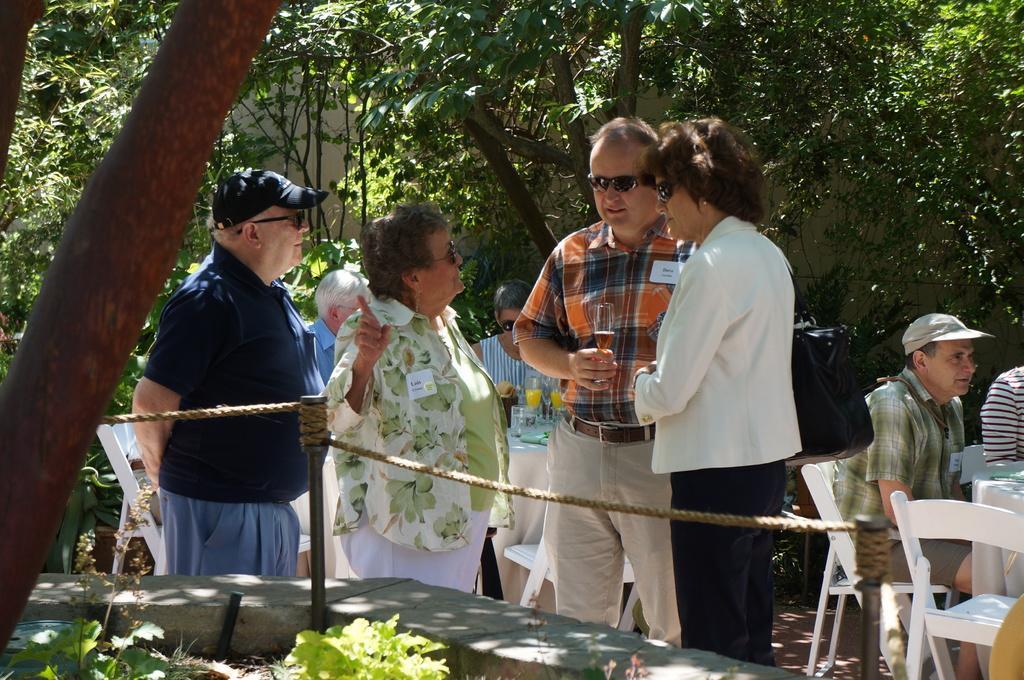How would you summarize this image in a sentence or two? In this image we can see some group of persons sitting on chairs, in the foreground of the image there are some persons standing and a person holding glass in his hands, in the background of the image there are some glasses, bottles on table, there are some trees, wall. 